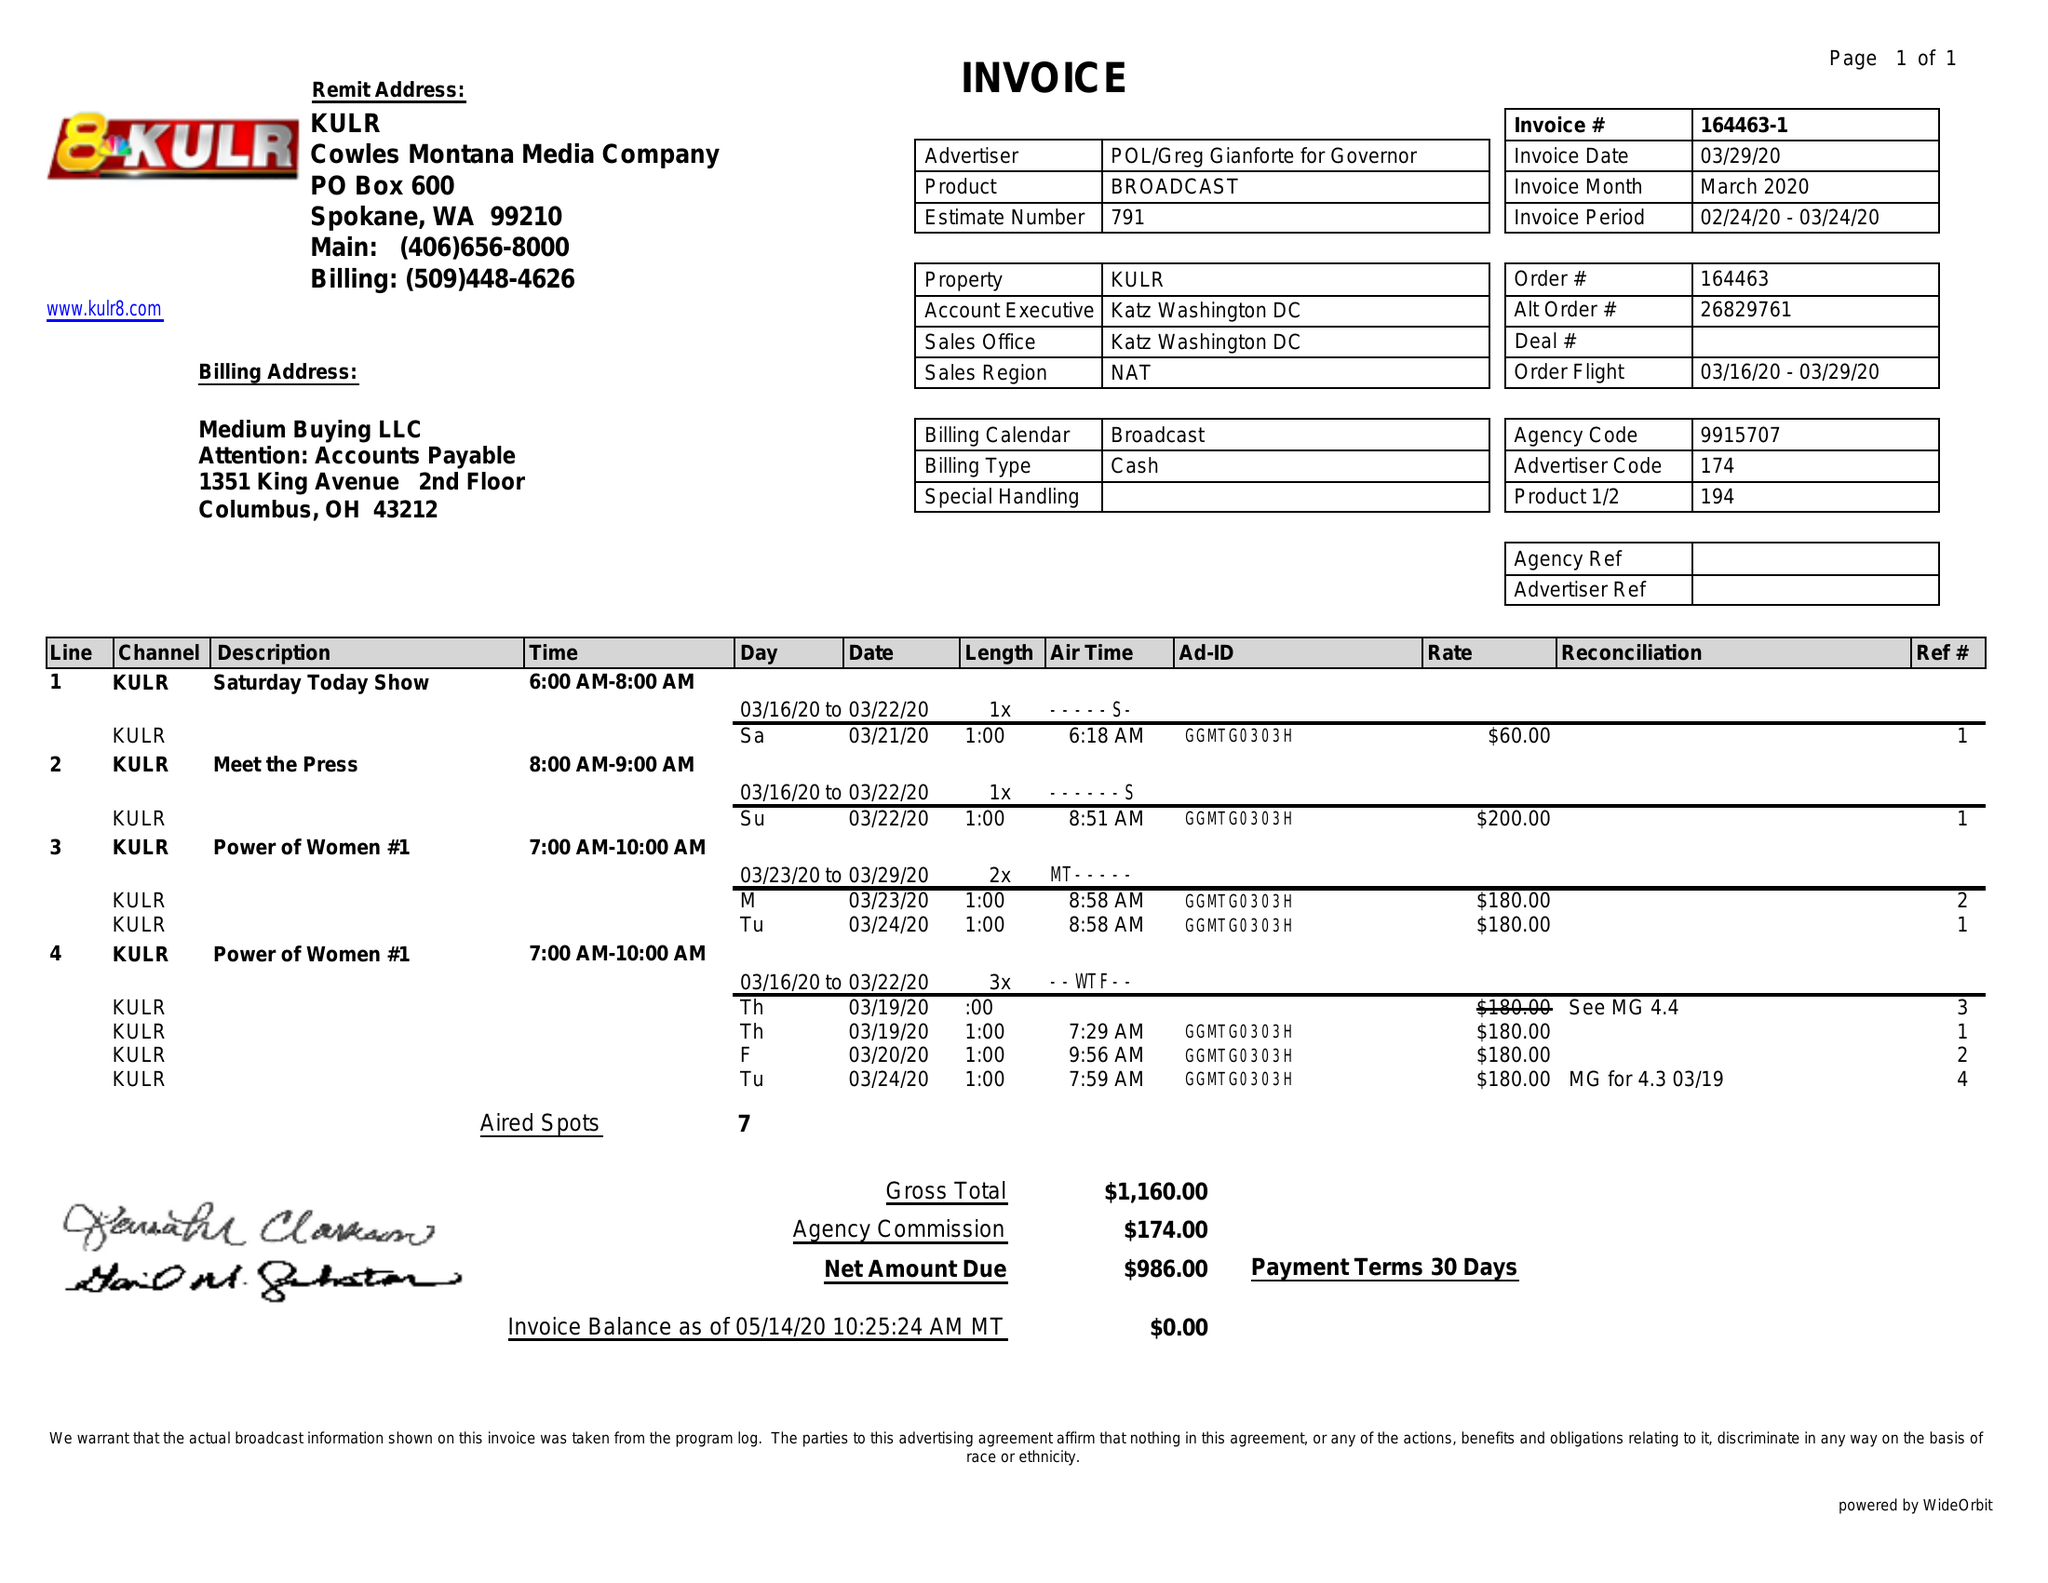What is the value for the advertiser?
Answer the question using a single word or phrase. POL/GREGGIANFORTEFORGOVERNOR 